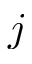Convert formula to latex. <formula><loc_0><loc_0><loc_500><loc_500>j</formula> 